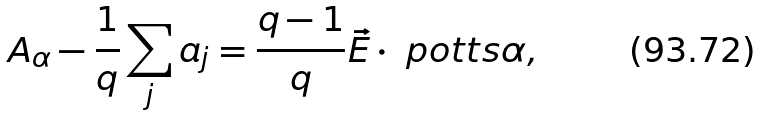Convert formula to latex. <formula><loc_0><loc_0><loc_500><loc_500>A _ { \alpha } - \frac { 1 } { q } \sum _ { j } a _ { j } = \frac { q - 1 } { q } \vec { E } \cdot \ p o t t s { \alpha } ,</formula> 